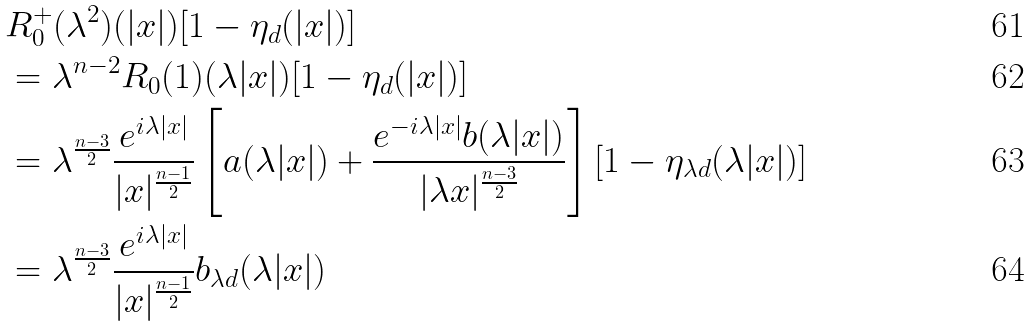<formula> <loc_0><loc_0><loc_500><loc_500>& R _ { 0 } ^ { + } ( \lambda ^ { 2 } ) ( | x | ) [ 1 - \eta _ { d } ( | x | ) ] \\ & = \lambda ^ { n - 2 } R _ { 0 } ( 1 ) ( \lambda | x | ) [ 1 - \eta _ { d } ( | x | ) ] \\ & = \lambda ^ { \frac { n - 3 } { 2 } } \frac { e ^ { i \lambda | x | } } { | x | ^ { \frac { n - 1 } { 2 } } } \left [ a ( \lambda | x | ) + \frac { e ^ { - i \lambda | x | } b ( \lambda | x | ) } { | \lambda x | ^ { \frac { n - 3 } { 2 } } } \right ] [ 1 - \eta _ { \lambda d } ( \lambda | x | ) ] \\ & = \lambda ^ { \frac { n - 3 } { 2 } } \frac { e ^ { i \lambda | x | } } { | x | ^ { \frac { n - 1 } { 2 } } } b _ { \lambda d } ( \lambda | x | )</formula> 